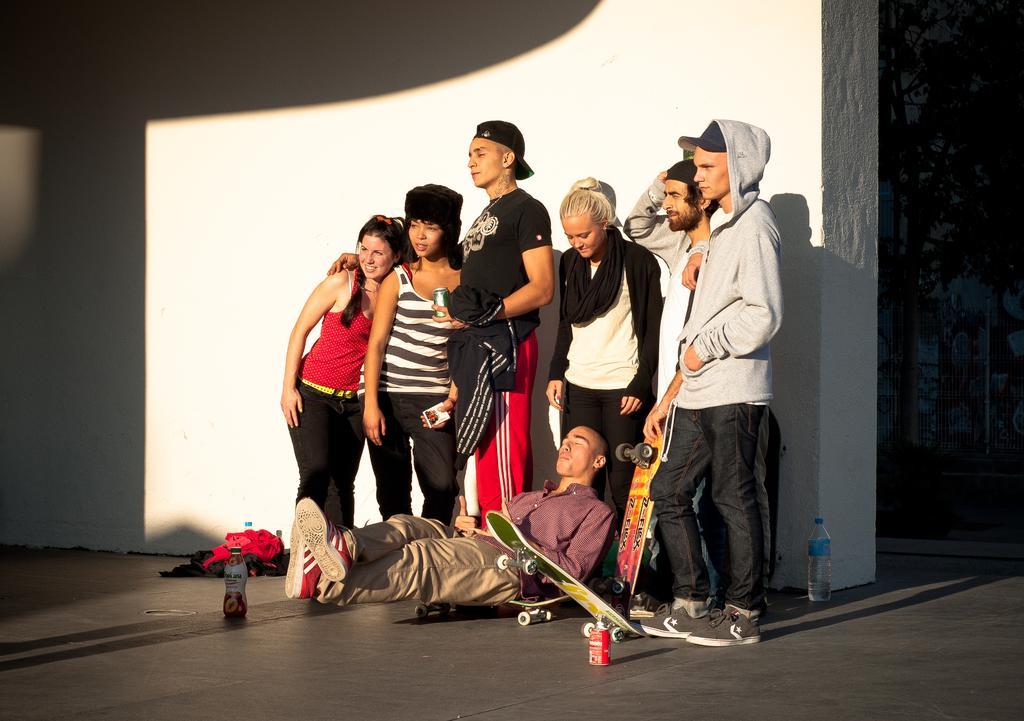How would you summarize this image in a sentence or two? In this image, we can see a group of people wearing clothes and standing in front of the wall. There is a person at the bottom of the image sitting on the skateboard. There is a bottle in the bottom left and in the bottom right of the image. 